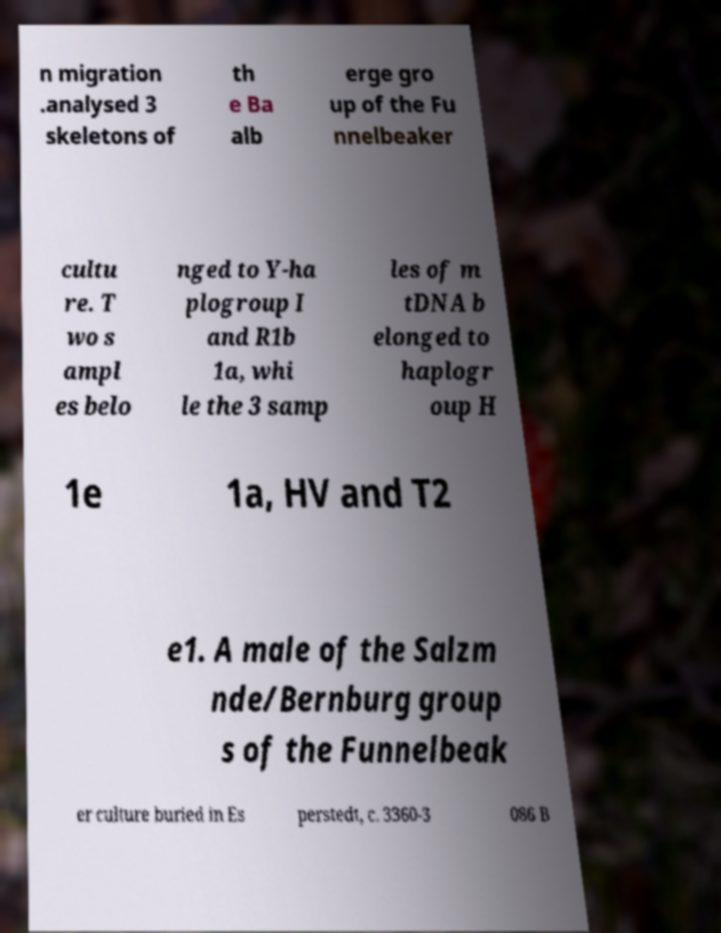Please identify and transcribe the text found in this image. n migration .analysed 3 skeletons of th e Ba alb erge gro up of the Fu nnelbeaker cultu re. T wo s ampl es belo nged to Y-ha plogroup I and R1b 1a, whi le the 3 samp les of m tDNA b elonged to haplogr oup H 1e 1a, HV and T2 e1. A male of the Salzm nde/Bernburg group s of the Funnelbeak er culture buried in Es perstedt, c. 3360-3 086 B 